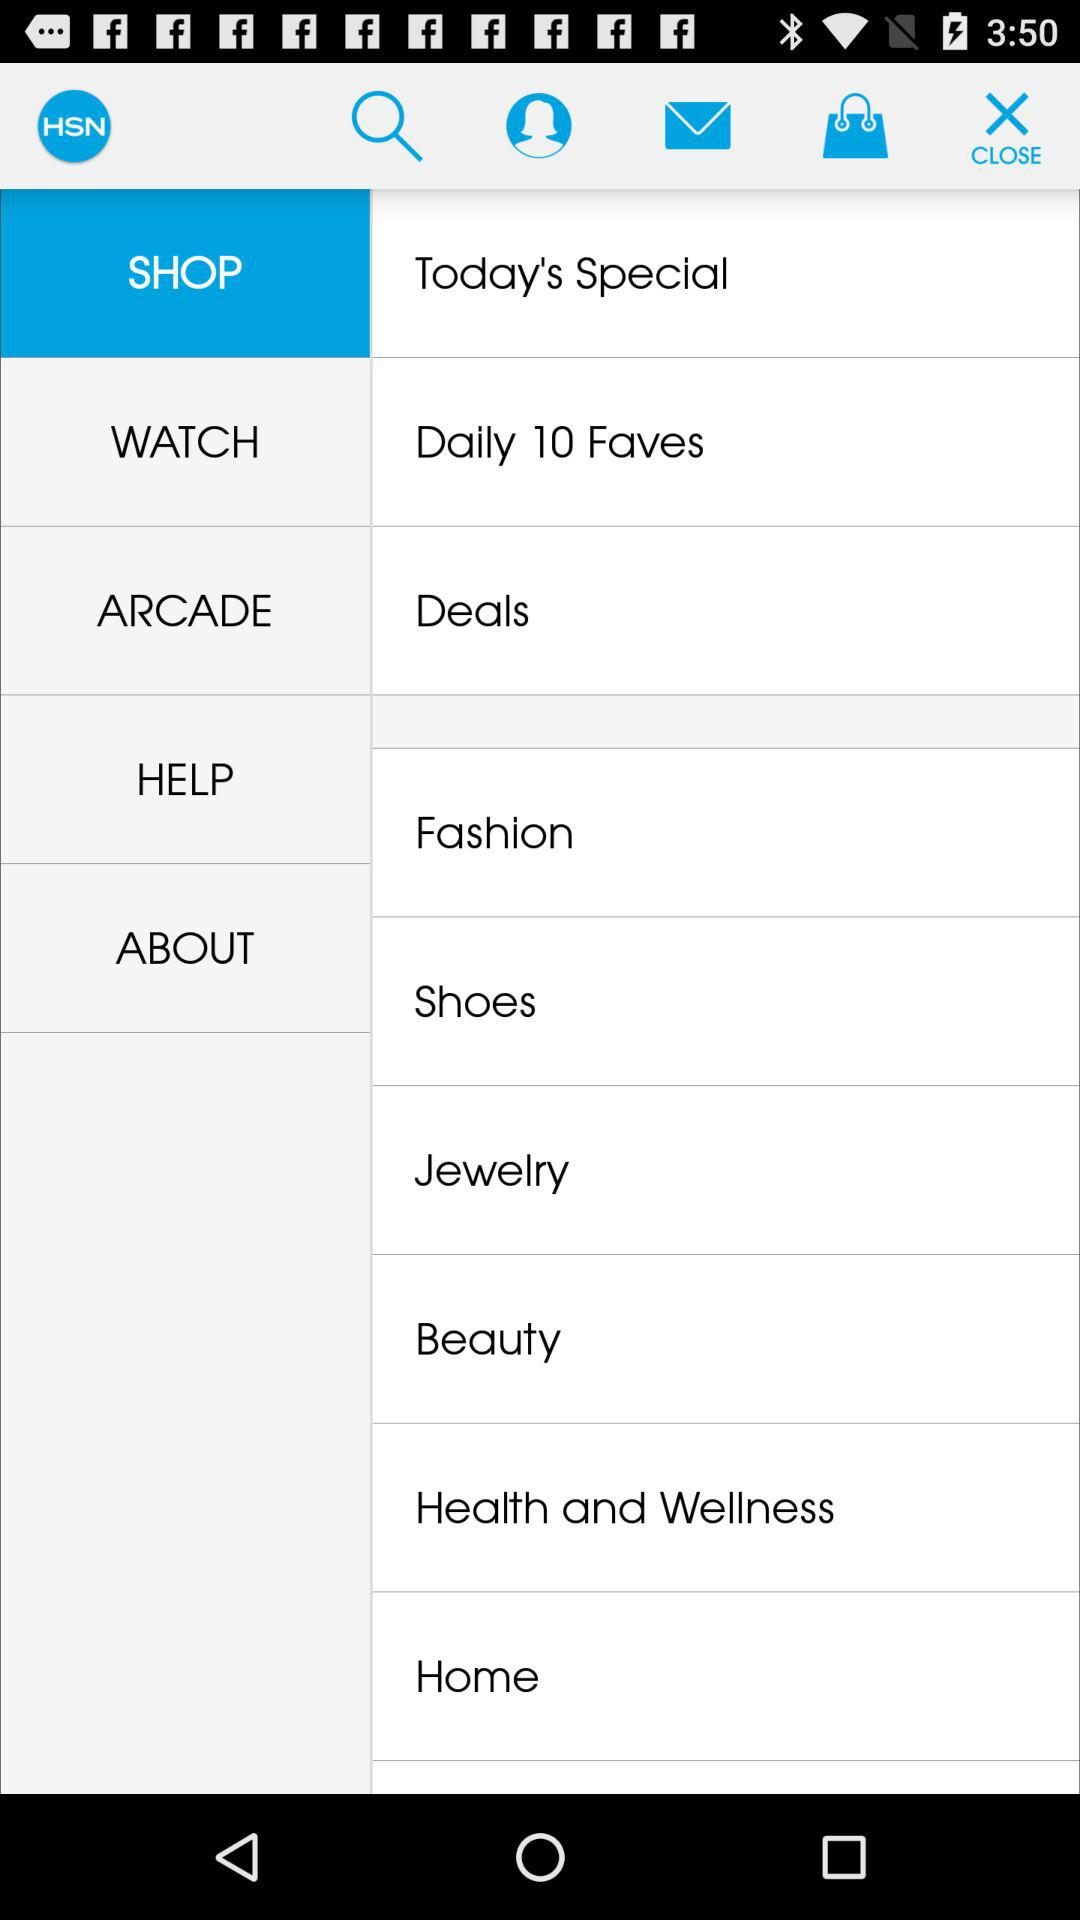Which item is currently selected? The currently selected item is "SHOP". 